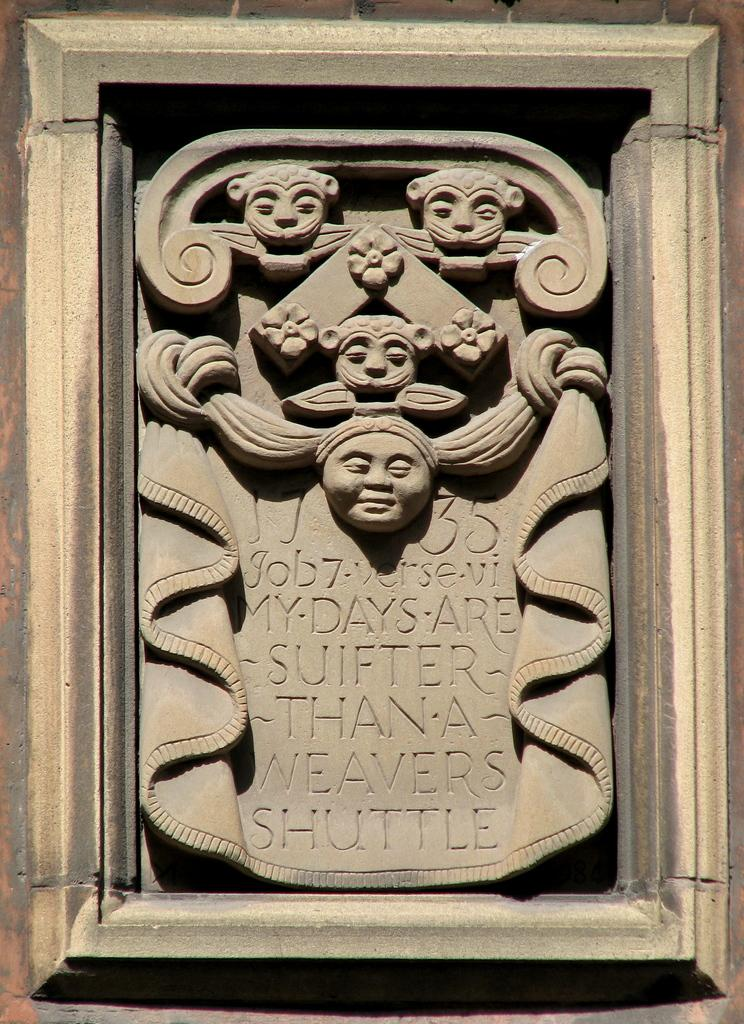What is on the wall in the image? There is a sculpture on the wall in the image. What else can be seen in the image besides the sculpture? There is some text in the image. How many friends are holding a chain in the image? There are no friends or chains present in the image. 